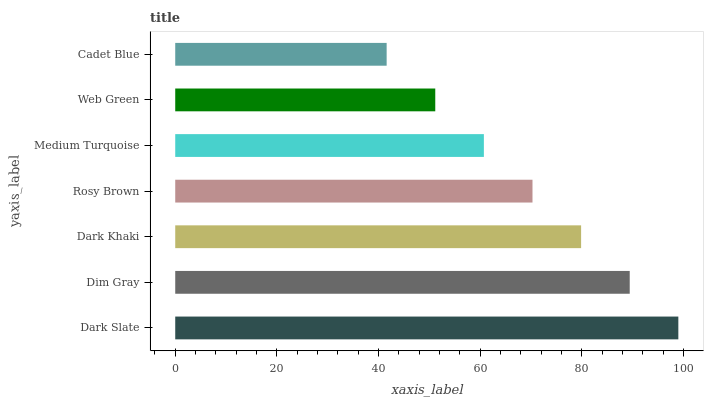Is Cadet Blue the minimum?
Answer yes or no. Yes. Is Dark Slate the maximum?
Answer yes or no. Yes. Is Dim Gray the minimum?
Answer yes or no. No. Is Dim Gray the maximum?
Answer yes or no. No. Is Dark Slate greater than Dim Gray?
Answer yes or no. Yes. Is Dim Gray less than Dark Slate?
Answer yes or no. Yes. Is Dim Gray greater than Dark Slate?
Answer yes or no. No. Is Dark Slate less than Dim Gray?
Answer yes or no. No. Is Rosy Brown the high median?
Answer yes or no. Yes. Is Rosy Brown the low median?
Answer yes or no. Yes. Is Cadet Blue the high median?
Answer yes or no. No. Is Cadet Blue the low median?
Answer yes or no. No. 